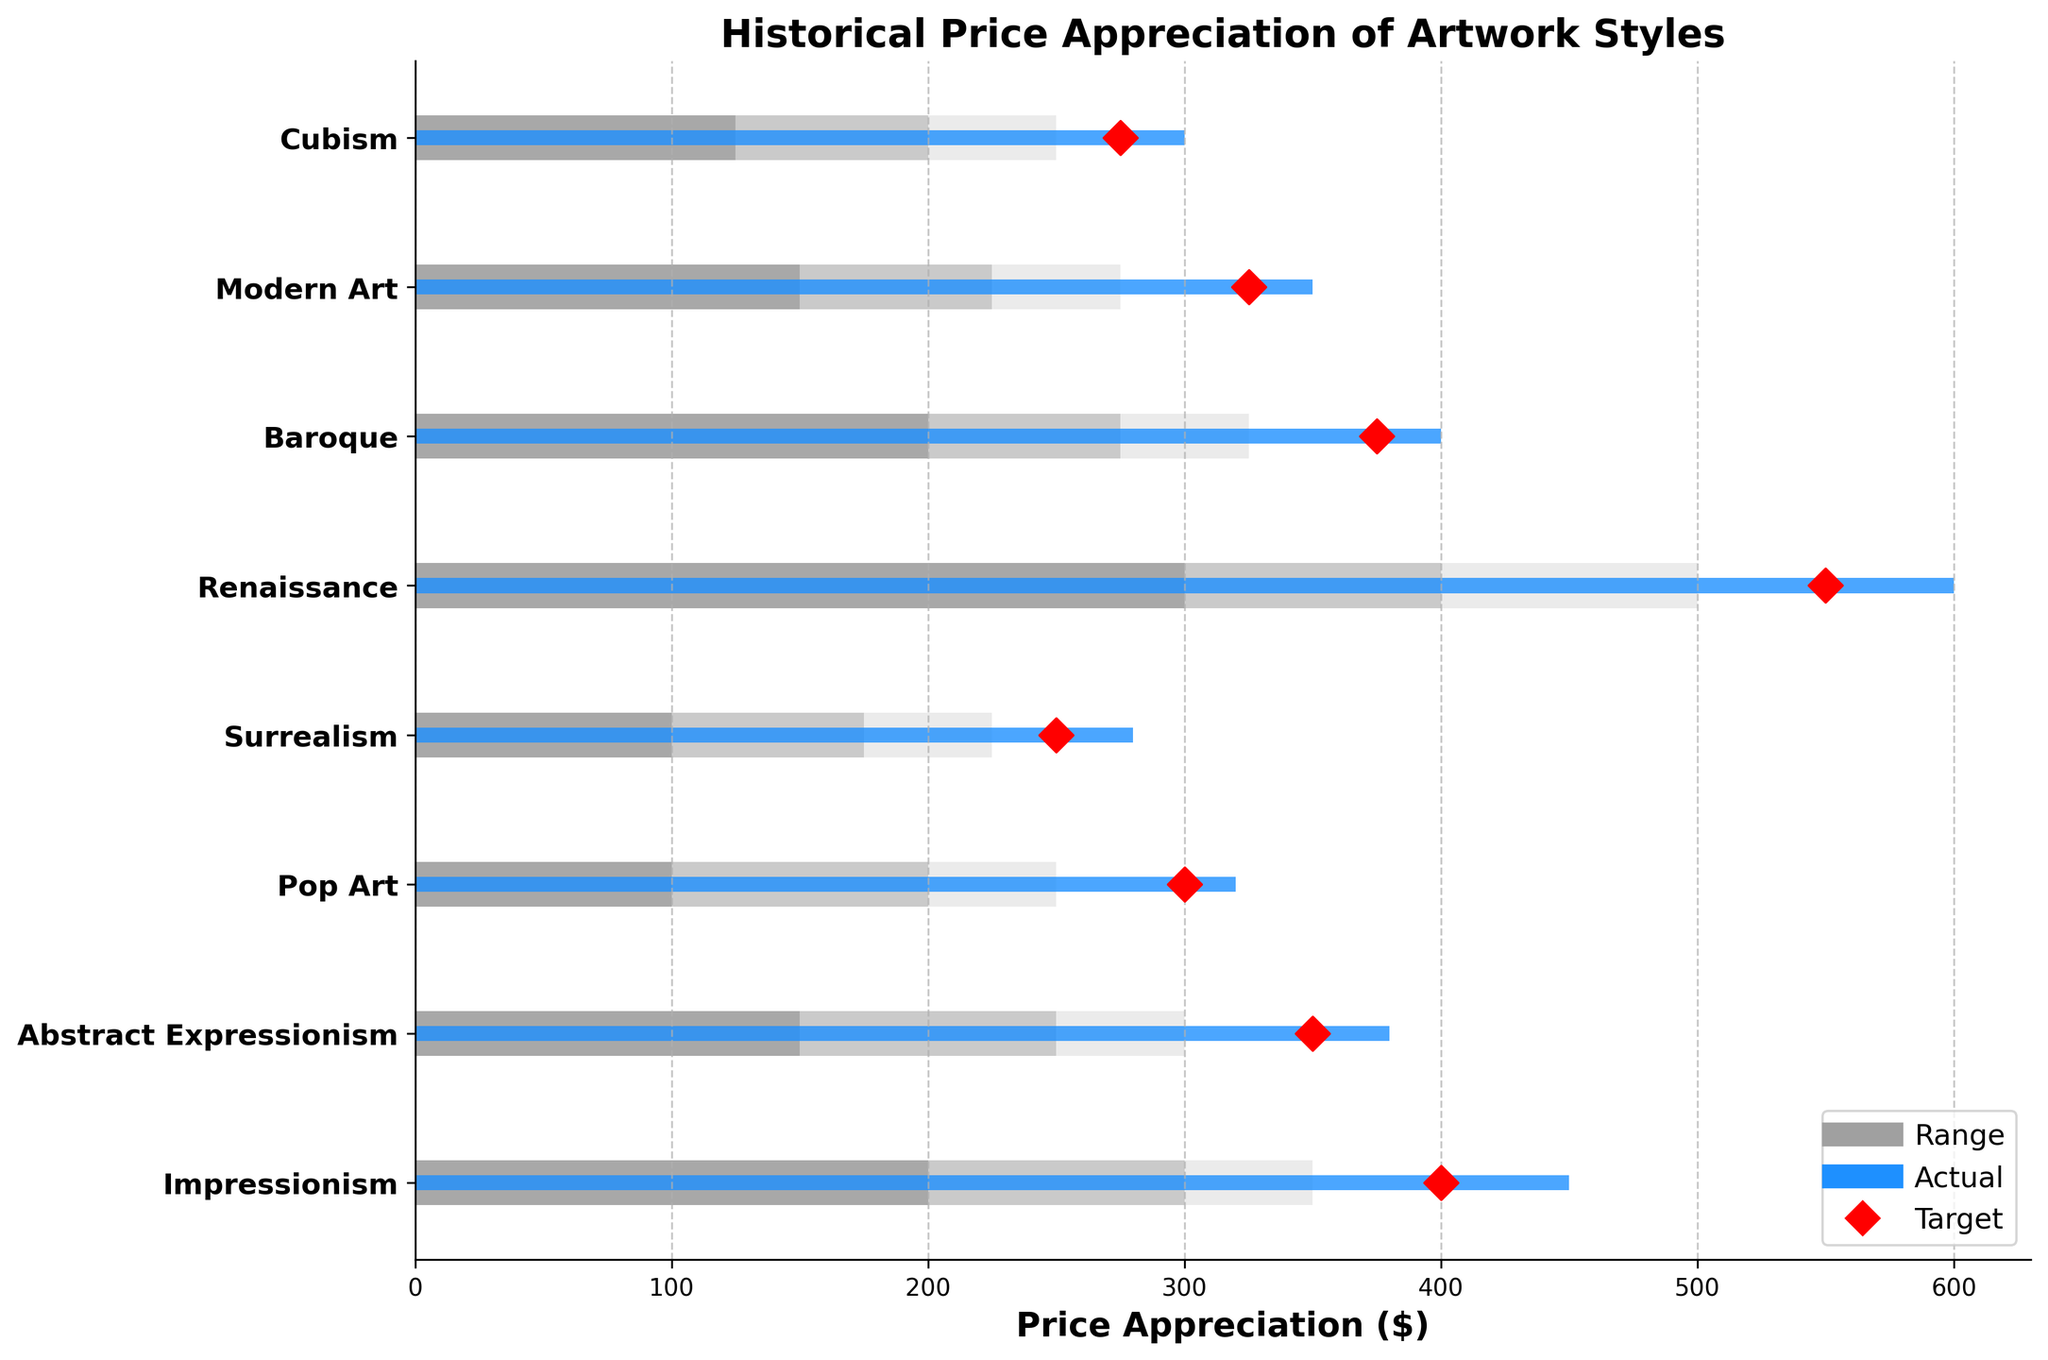what is the title of the figure? The title is clearly visible at the top of the figure. It reads "Historical Price Appreciation of Artwork Styles".
Answer: Historical Price Appreciation of Artwork Styles Which artwork style has the highest actual price appreciation? The blue bars represent the actual values, and the longest blue bar corresponds to "Renaissance".
Answer: Renaissance What is the target price appreciation for Impressionism? The red diamond markers represent the target values. The marker corresponding to Impressionism is at 400.
Answer: 400 Which styles have actual price appreciation greater than their target? By comparing each blue bar's length with its corresponding red diamond, "Impressionism", "Pop Art", "Surrealism", "Baroque" exceed their targets.
Answer: Impressionism, Pop Art, Surrealism, Baroque How much is the difference between the actual and target price appreciation for Renaissance? The actual value for Renaissance is 600, and the target value is 550. The difference is 600 - 550 = 50.
Answer: 50 Which style has the smallest difference between actual and target price appreciation? By calculating the differences for all styles, "Modern Art" has the smallest difference with actual 350 and target 325, giving 350 - 325 = 25.
Answer: Modern Art Which style has the widest range for the lowest threshold? The lowest threshold range (Range1) is indicated by the darkest shade of grey. Renaissance has the widest range from 0 to 300.
Answer: Renaissance Is the actual price appreciation for Cubism within its highest range? The actual value for Cubism is 300, while the highest range threshold (Range3) ends at 250. The actual value is outside the highest range.
Answer: No What's the average target price among all styles? The target prices are: 400, 350, 300, 250, 550, 375, 325, 275. Sum these to get 2825, and divide by the number of styles (8): 2825 / 8 = 353.13.
Answer: 353.13 